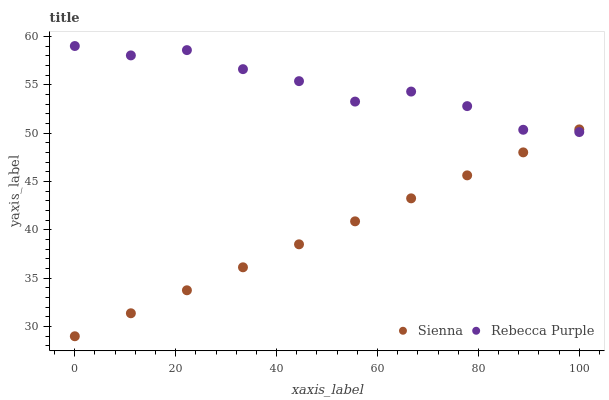Does Sienna have the minimum area under the curve?
Answer yes or no. Yes. Does Rebecca Purple have the maximum area under the curve?
Answer yes or no. Yes. Does Rebecca Purple have the minimum area under the curve?
Answer yes or no. No. Is Sienna the smoothest?
Answer yes or no. Yes. Is Rebecca Purple the roughest?
Answer yes or no. Yes. Is Rebecca Purple the smoothest?
Answer yes or no. No. Does Sienna have the lowest value?
Answer yes or no. Yes. Does Rebecca Purple have the lowest value?
Answer yes or no. No. Does Rebecca Purple have the highest value?
Answer yes or no. Yes. Does Rebecca Purple intersect Sienna?
Answer yes or no. Yes. Is Rebecca Purple less than Sienna?
Answer yes or no. No. Is Rebecca Purple greater than Sienna?
Answer yes or no. No. 